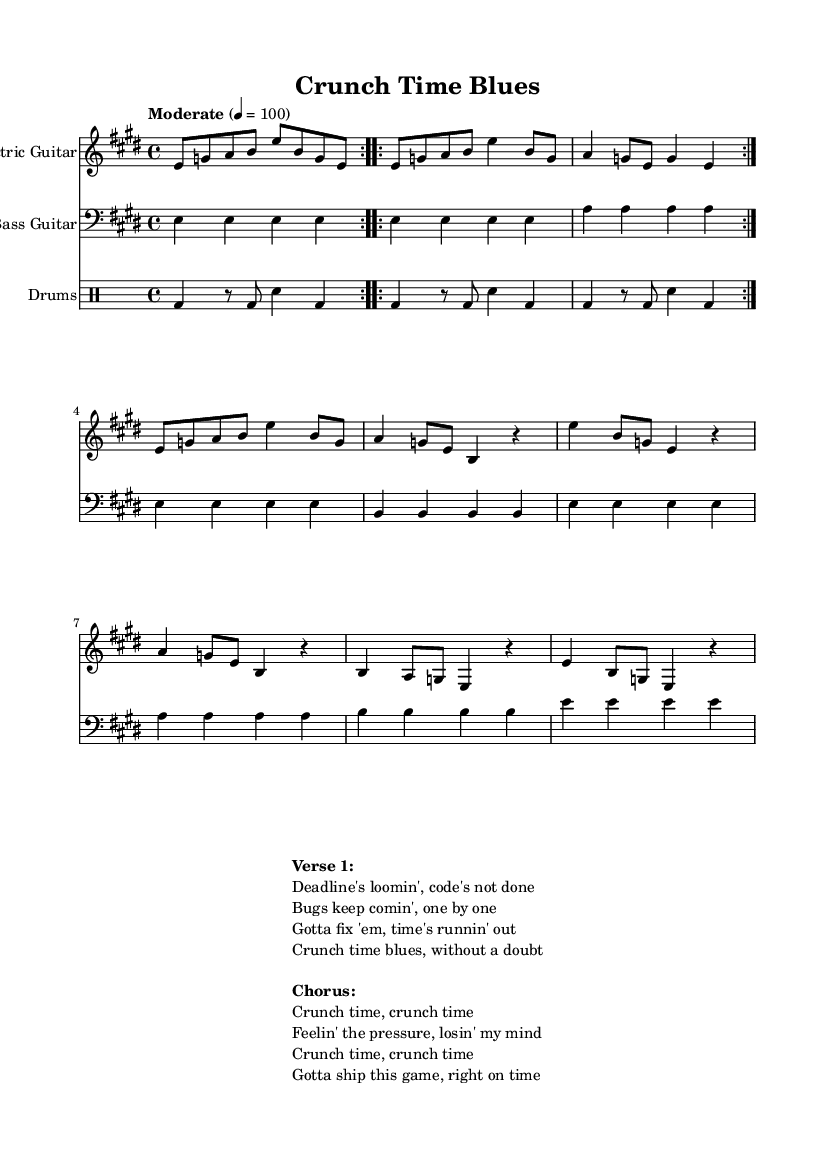What is the key signature of this music? The key signature is E major, which includes four sharps (F#, C#, G#, D#). This can be deduced from the global settings at the beginning of the code, where it states \key e \major.
Answer: E major What is the time signature of this music? The time signature is 4/4, indicated by \time 4/4 in the global settings. This means there are four beats in each measure and a quarter note gets one beat.
Answer: 4/4 What is the tempo marking of this piece? The tempo marking is "Moderate 4 = 100", indicating a moderate pace at a quarter note equals 100 beats per minute. This is specified in the global section under \tempo.
Answer: Moderate 4 = 100 How many measures are in the intro section? The intro section consists of 4 measures. This is identified by counting the number of measures in the electric guitar part where the riff is played, which is repeated twice. Each iteration contains 2 measures, giving a total of 4.
Answer: 4 measures What instruments are featured in the music? The instruments featured are Electric Guitar, Bass Guitar, and Drums. This can be seen in the different staff sections for each instrument specified in the score.
Answer: Electric Guitar, Bass Guitar, Drums What is the primary theme of the lyrics? The primary theme of the lyrics revolves around the stress and urgency of meeting game development deadlines, as expressed in the lines describing looming deadlines and pressure. This can be analyzed by reading the verses and chorus provided in the markup section.
Answer: Crunch time blues How is the structure of the song organized? The structure of the song follows a pattern of Intro, Verse, and Chorus, with each section clearly defined. This organization is evident from the different parts labeled in the score and the repeated elements in the lyrics.
Answer: Intro, Verse, Chorus 